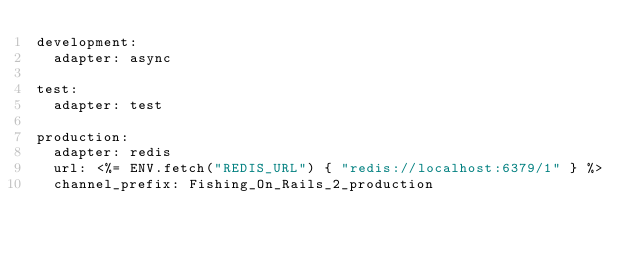<code> <loc_0><loc_0><loc_500><loc_500><_YAML_>development:
  adapter: async

test:
  adapter: test

production:
  adapter: redis
  url: <%= ENV.fetch("REDIS_URL") { "redis://localhost:6379/1" } %>
  channel_prefix: Fishing_On_Rails_2_production
</code> 